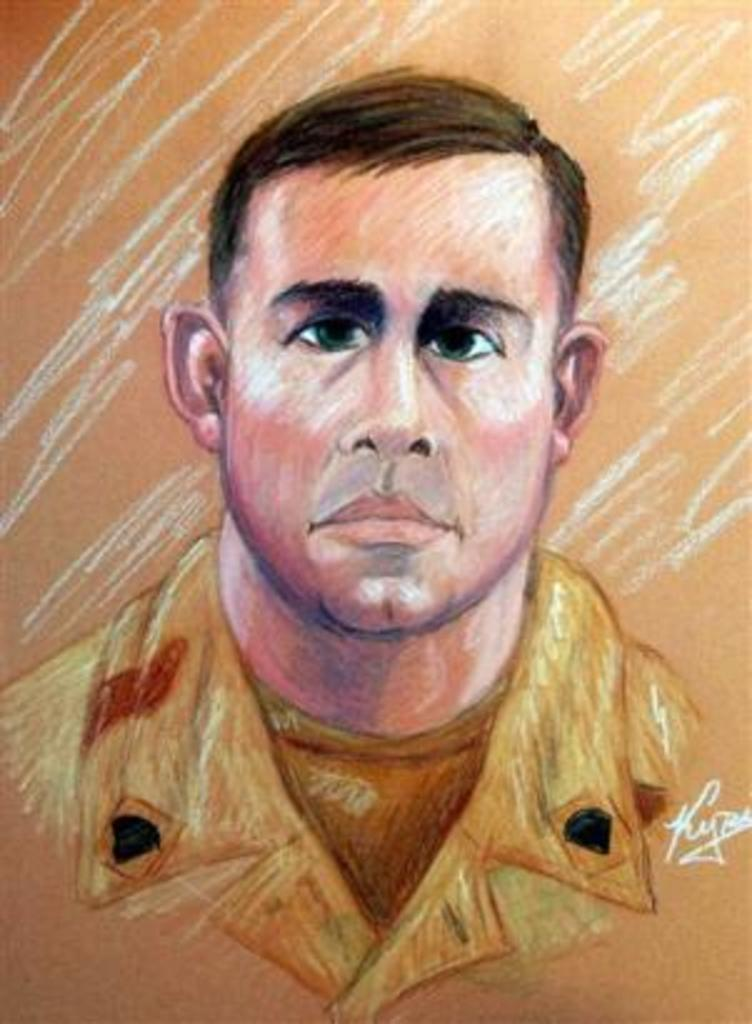What type of artwork is the image? The image is a painting. Who or what is the main subject of the painting? There is a person depicted in the painting. Is there any text present in the painting? Yes, there is text located at the bottom right of the painting. What type of plantation is shown in the painting? There is no plantation depicted in the painting; it features a person and text. How does the person in the painting contribute to the profit of the plantation? The painting does not depict a plantation or any activity related to profit, so it is not possible to answer this question. 